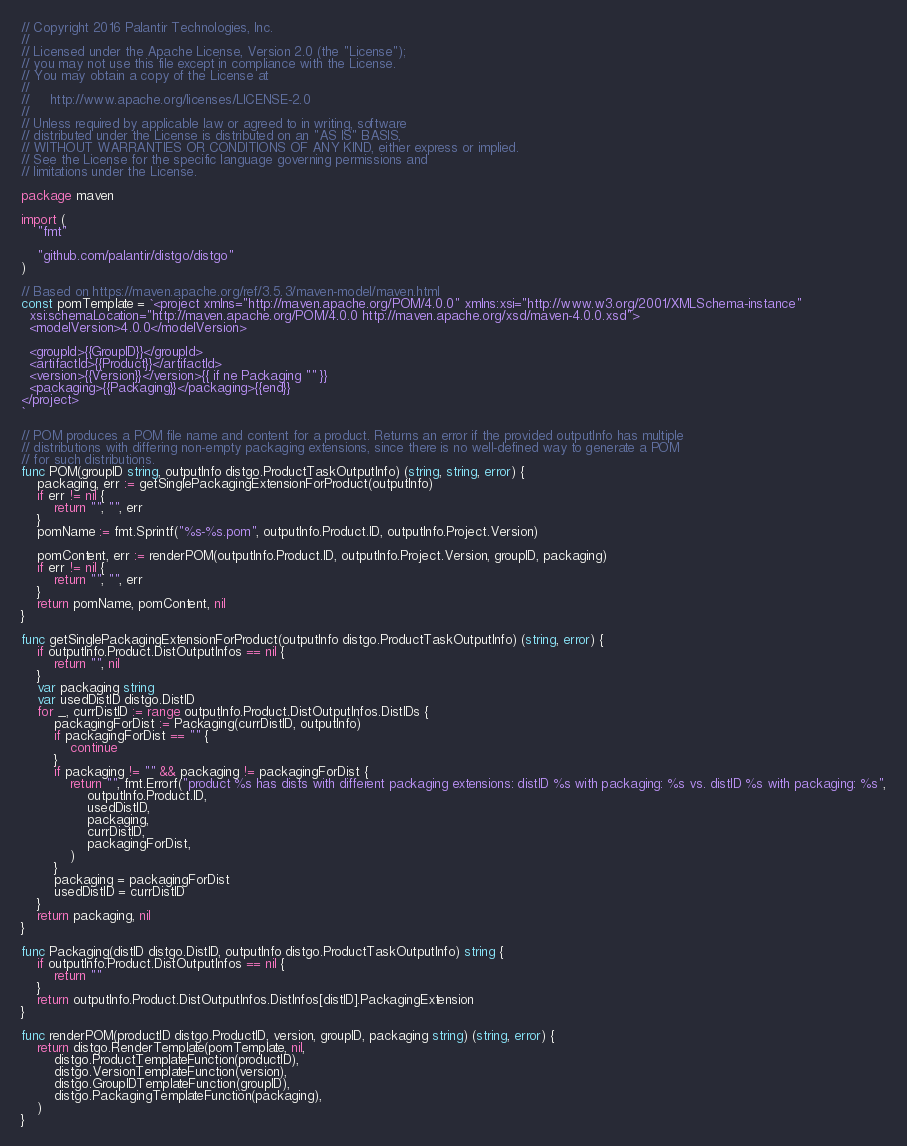Convert code to text. <code><loc_0><loc_0><loc_500><loc_500><_Go_>// Copyright 2016 Palantir Technologies, Inc.
//
// Licensed under the Apache License, Version 2.0 (the "License");
// you may not use this file except in compliance with the License.
// You may obtain a copy of the License at
//
//     http://www.apache.org/licenses/LICENSE-2.0
//
// Unless required by applicable law or agreed to in writing, software
// distributed under the License is distributed on an "AS IS" BASIS,
// WITHOUT WARRANTIES OR CONDITIONS OF ANY KIND, either express or implied.
// See the License for the specific language governing permissions and
// limitations under the License.

package maven

import (
	"fmt"

	"github.com/palantir/distgo/distgo"
)

// Based on https://maven.apache.org/ref/3.5.3/maven-model/maven.html
const pomTemplate = `<project xmlns="http://maven.apache.org/POM/4.0.0" xmlns:xsi="http://www.w3.org/2001/XMLSchema-instance"
  xsi:schemaLocation="http://maven.apache.org/POM/4.0.0 http://maven.apache.org/xsd/maven-4.0.0.xsd">
  <modelVersion>4.0.0</modelVersion>

  <groupId>{{GroupID}}</groupId>
  <artifactId>{{Product}}</artifactId>
  <version>{{Version}}</version>{{ if ne Packaging "" }}
  <packaging>{{Packaging}}</packaging>{{end}}
</project>
`

// POM produces a POM file name and content for a product. Returns an error if the provided outputInfo has multiple
// distributions with differing non-empty packaging extensions, since there is no well-defined way to generate a POM
// for such distributions.
func POM(groupID string, outputInfo distgo.ProductTaskOutputInfo) (string, string, error) {
	packaging, err := getSinglePackagingExtensionForProduct(outputInfo)
	if err != nil {
		return "", "", err
	}
	pomName := fmt.Sprintf("%s-%s.pom", outputInfo.Product.ID, outputInfo.Project.Version)

	pomContent, err := renderPOM(outputInfo.Product.ID, outputInfo.Project.Version, groupID, packaging)
	if err != nil {
		return "", "", err
	}
	return pomName, pomContent, nil
}

func getSinglePackagingExtensionForProduct(outputInfo distgo.ProductTaskOutputInfo) (string, error) {
	if outputInfo.Product.DistOutputInfos == nil {
		return "", nil
	}
	var packaging string
	var usedDistID distgo.DistID
	for _, currDistID := range outputInfo.Product.DistOutputInfos.DistIDs {
		packagingForDist := Packaging(currDistID, outputInfo)
		if packagingForDist == "" {
			continue
		}
		if packaging != "" && packaging != packagingForDist {
			return "", fmt.Errorf("product %s has dists with different packaging extensions: distID %s with packaging: %s vs. distID %s with packaging: %s",
				outputInfo.Product.ID,
				usedDistID,
				packaging,
				currDistID,
				packagingForDist,
			)
		}
		packaging = packagingForDist
		usedDistID = currDistID
	}
	return packaging, nil
}

func Packaging(distID distgo.DistID, outputInfo distgo.ProductTaskOutputInfo) string {
	if outputInfo.Product.DistOutputInfos == nil {
		return ""
	}
	return outputInfo.Product.DistOutputInfos.DistInfos[distID].PackagingExtension
}

func renderPOM(productID distgo.ProductID, version, groupID, packaging string) (string, error) {
	return distgo.RenderTemplate(pomTemplate, nil,
		distgo.ProductTemplateFunction(productID),
		distgo.VersionTemplateFunction(version),
		distgo.GroupIDTemplateFunction(groupID),
		distgo.PackagingTemplateFunction(packaging),
	)
}
</code> 